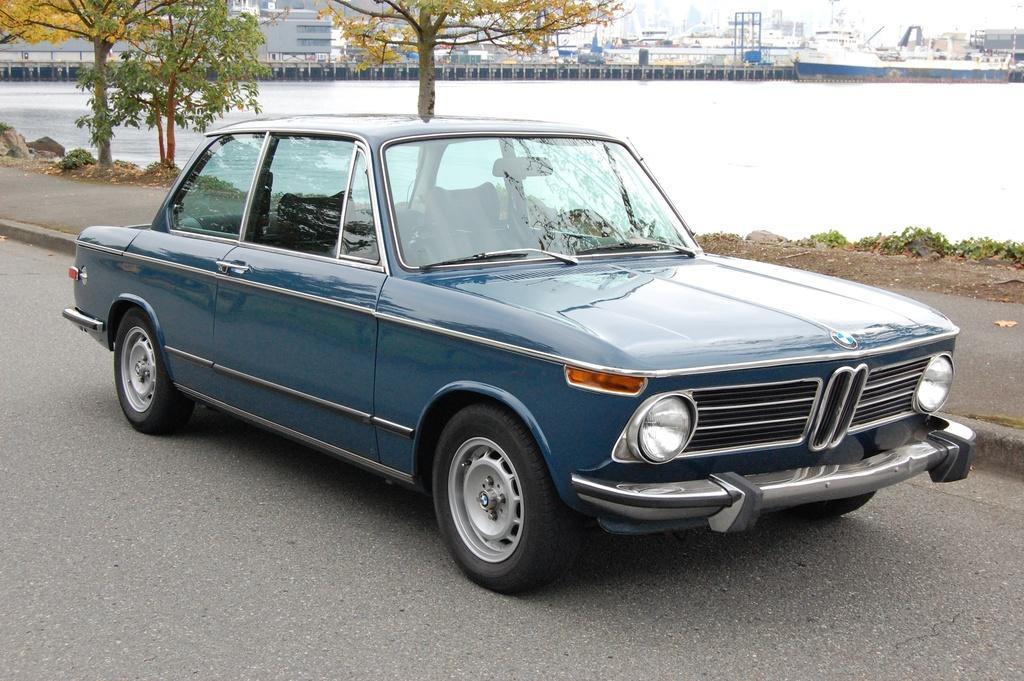Can you describe this image briefly? In this image we a vehicle parked on the ground. In the background, we can see some trees, buildings and some poles. In the right side of the image we can see a ship in the water and some plants. 